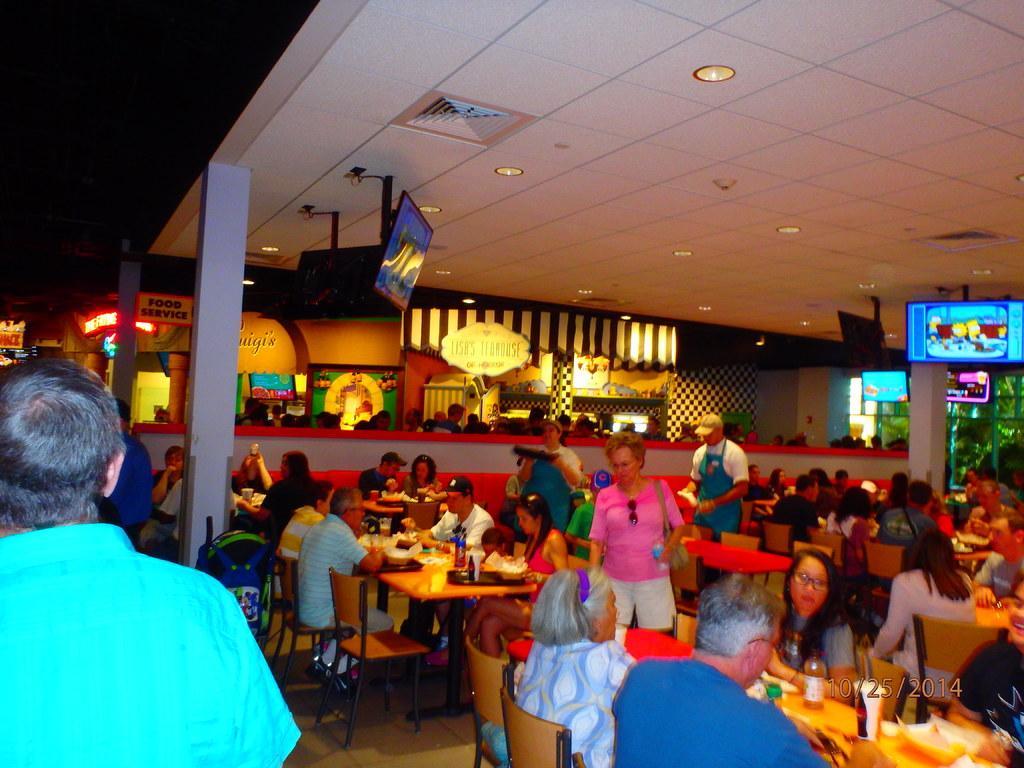Can you describe this image briefly? It looks like a food court. Many people are sitting and eating. We can see a TV screens on the top of the roofs and some light also. And there are some pillars. We can see a wall. There are many tables, chairs. 